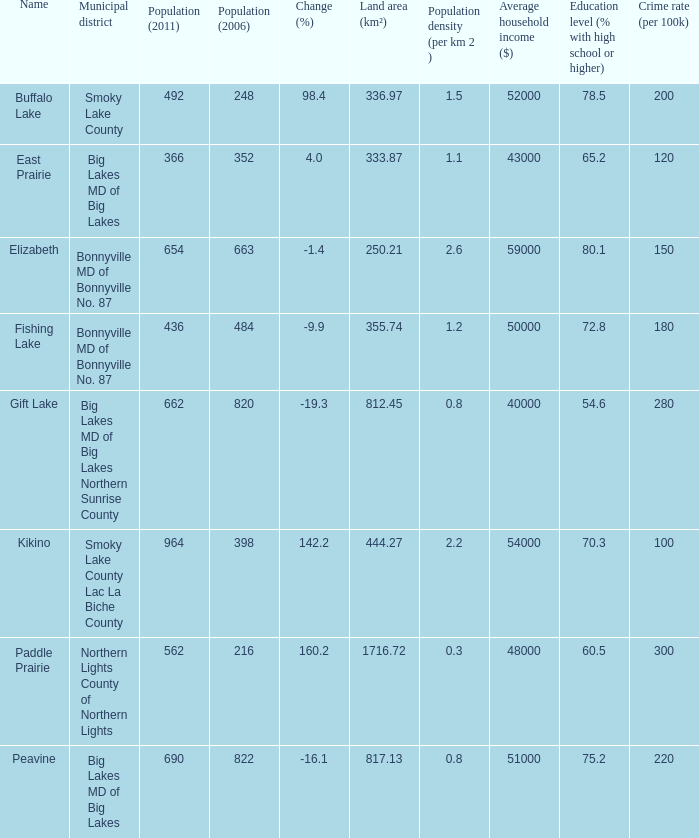What is the population density in Buffalo Lake? 1.5. 